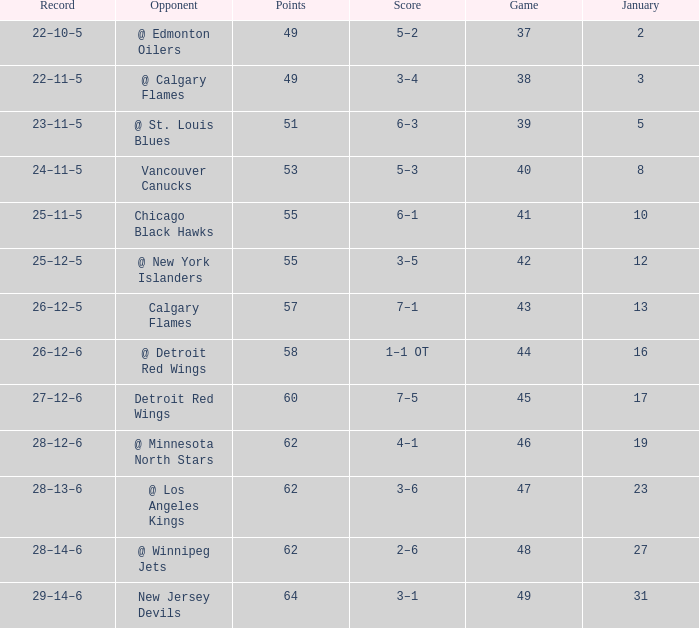How much January has a Record of 26–12–6, and Points smaller than 58? None. 